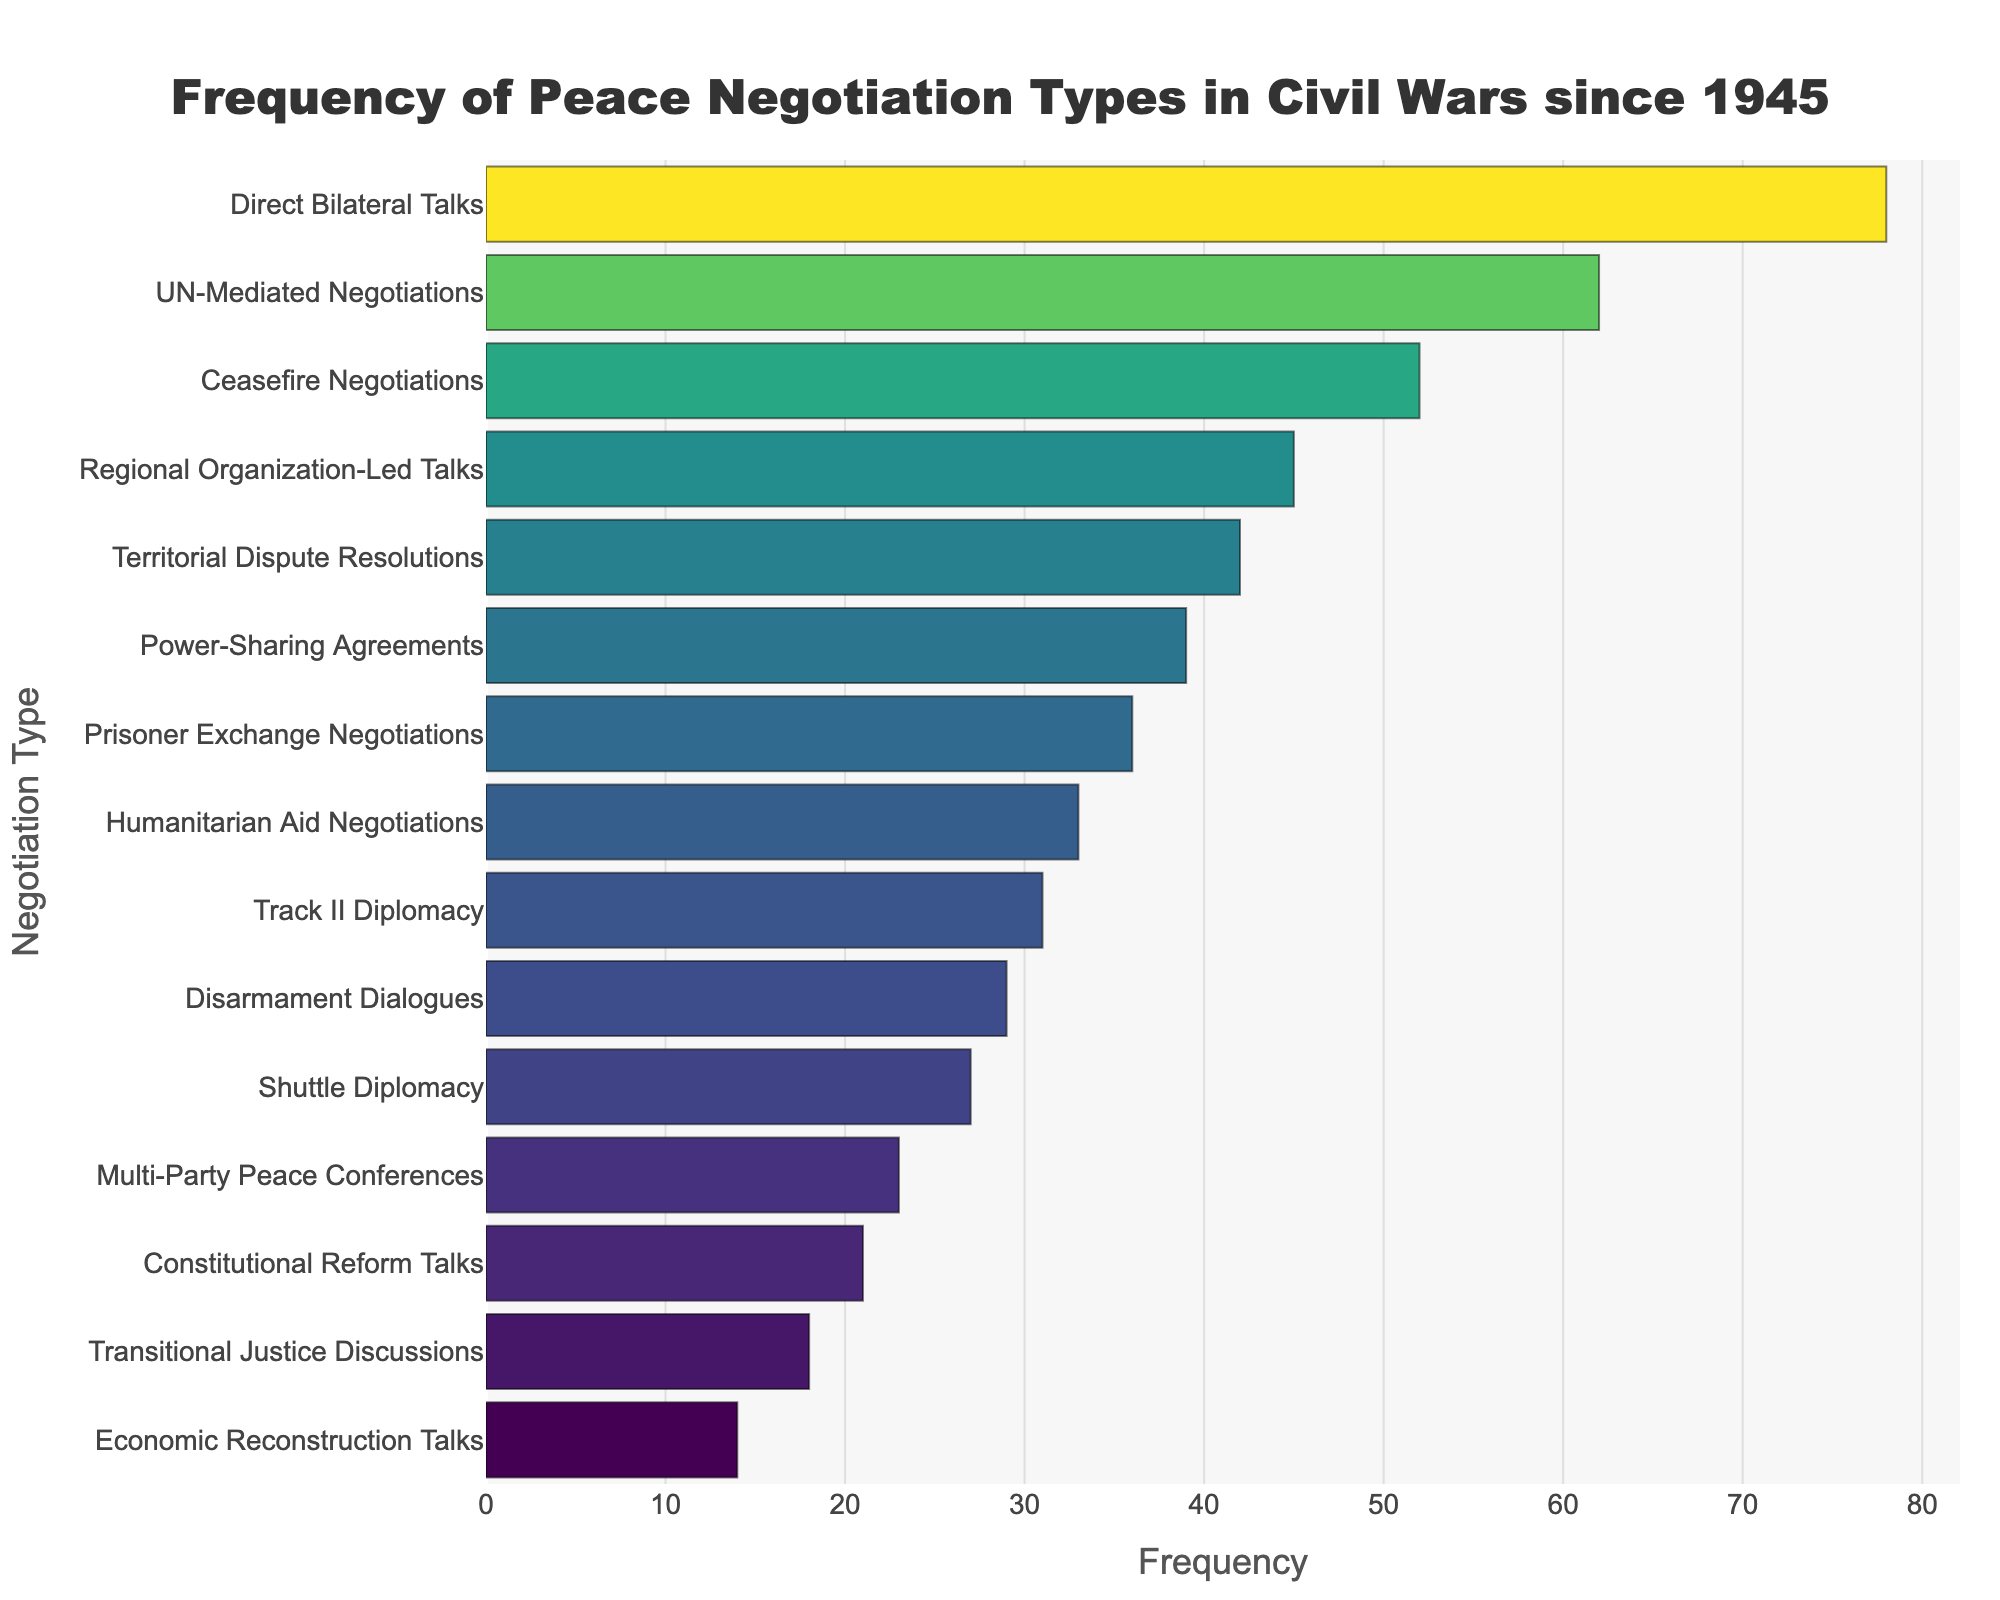What's the title of the plot? The title is typically displayed at the top of the figure and often provides a brief summary of the content of the plot. In this case, the title indicates the data being presented.
Answer: Frequency of Peace Negotiation Types in Civil Wars since 1945 Which type of peace negotiation has the highest frequency? By examining the y-axis labels and comparing the corresponding bar lengths, we can identify the type of negotiation that extends the furthest on the x-axis.
Answer: Direct Bilateral Talks How many types of negotiations have a frequency greater than 50? To answer this, look at the x-axis and count how many bars extend beyond the 50 mark.
Answer: Three Compare the frequency of "Shuttle Diplomacy" and "Track II Diplomacy". Which one is higher? Find "Shuttle Diplomacy" and "Track II Diplomacy" on the y-axis and compare the lengths of their corresponding bars.
Answer: Track II Diplomacy What is the total frequency of "Ceasefire Negotiations" and "Power-Sharing Agreements"? Locate the bars for "Ceasefire Negotiations" and "Power-Sharing Agreements" and sum up their frequencies (52 and 39, respectively).
Answer: 91 Which type of negotiation has the lowest frequency? By examining the y-axis labels and comparing the corresponding bar lengths, we can identify the shortest bar, indicating the lowest frequency.
Answer: Economic Reconstruction Talks What is the difference in frequency between "UN-Mediated Negotiations" and "Humanitarian Aid Negotiations"? Find the bars for "UN-Mediated Negotiations" and "Humanitarian Aid Negotiations" and calculate the difference between their frequencies (62 and 33, respectively).
Answer: 29 How many negotiation types have frequencies between 20 and 40? Look for bars that begin after the 20 mark on the x-axis and end before the 40 mark. Count these bars to find the answer.
Answer: Six Which two negotiation types have the closest frequencies? Inspect the lengths of the bars and find the two that have the smallest difference in their frequencies.
Answer: Economic Reconstruction Talks and Transitional Justice Discussions What's the average frequency of the negotiation types listed in the plot? Sum all the frequencies and divide by the number of negotiation types (sum of all frequencies = 550, number of types = 15, thus 550/15).
Answer: 36.67 